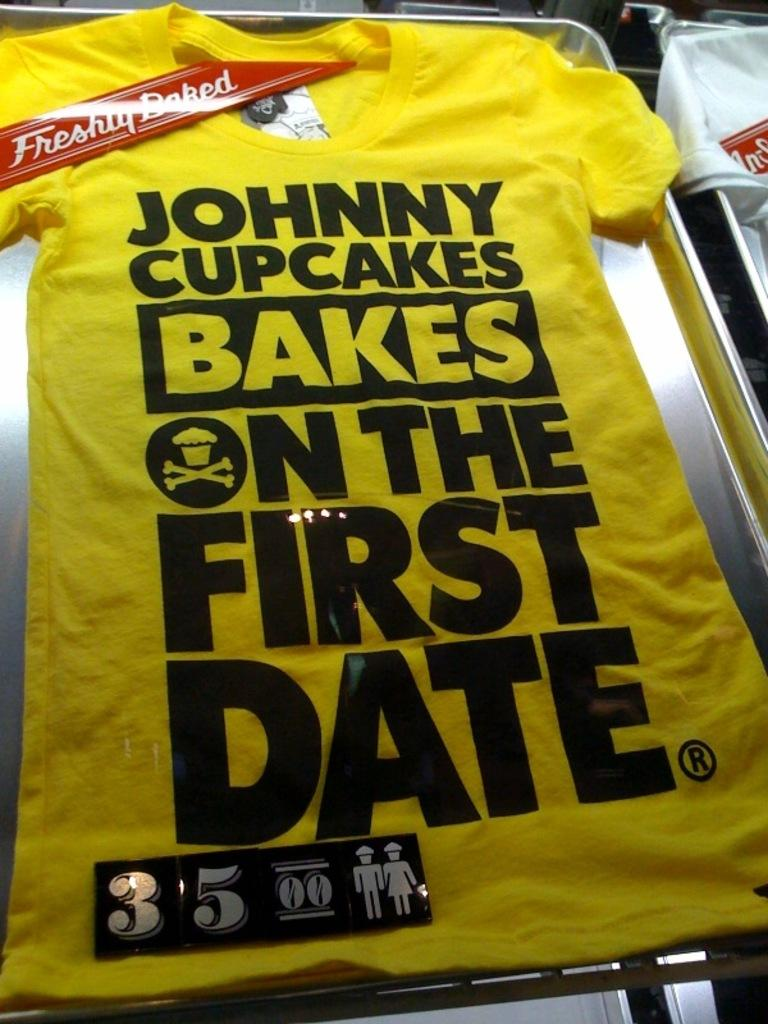<image>
Share a concise interpretation of the image provided. A shirt has a red tag that says freshly baked on it. 